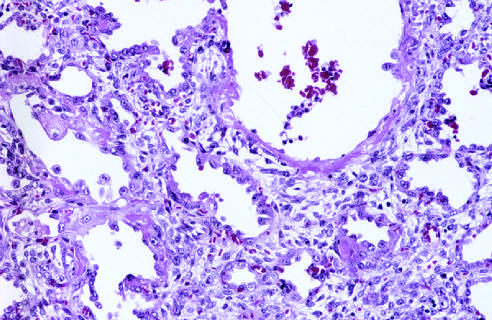what are numerous reactive type ii pneumocytes seen at, associated with regeneration and repair?
Answer the question using a single word or phrase. This stage 